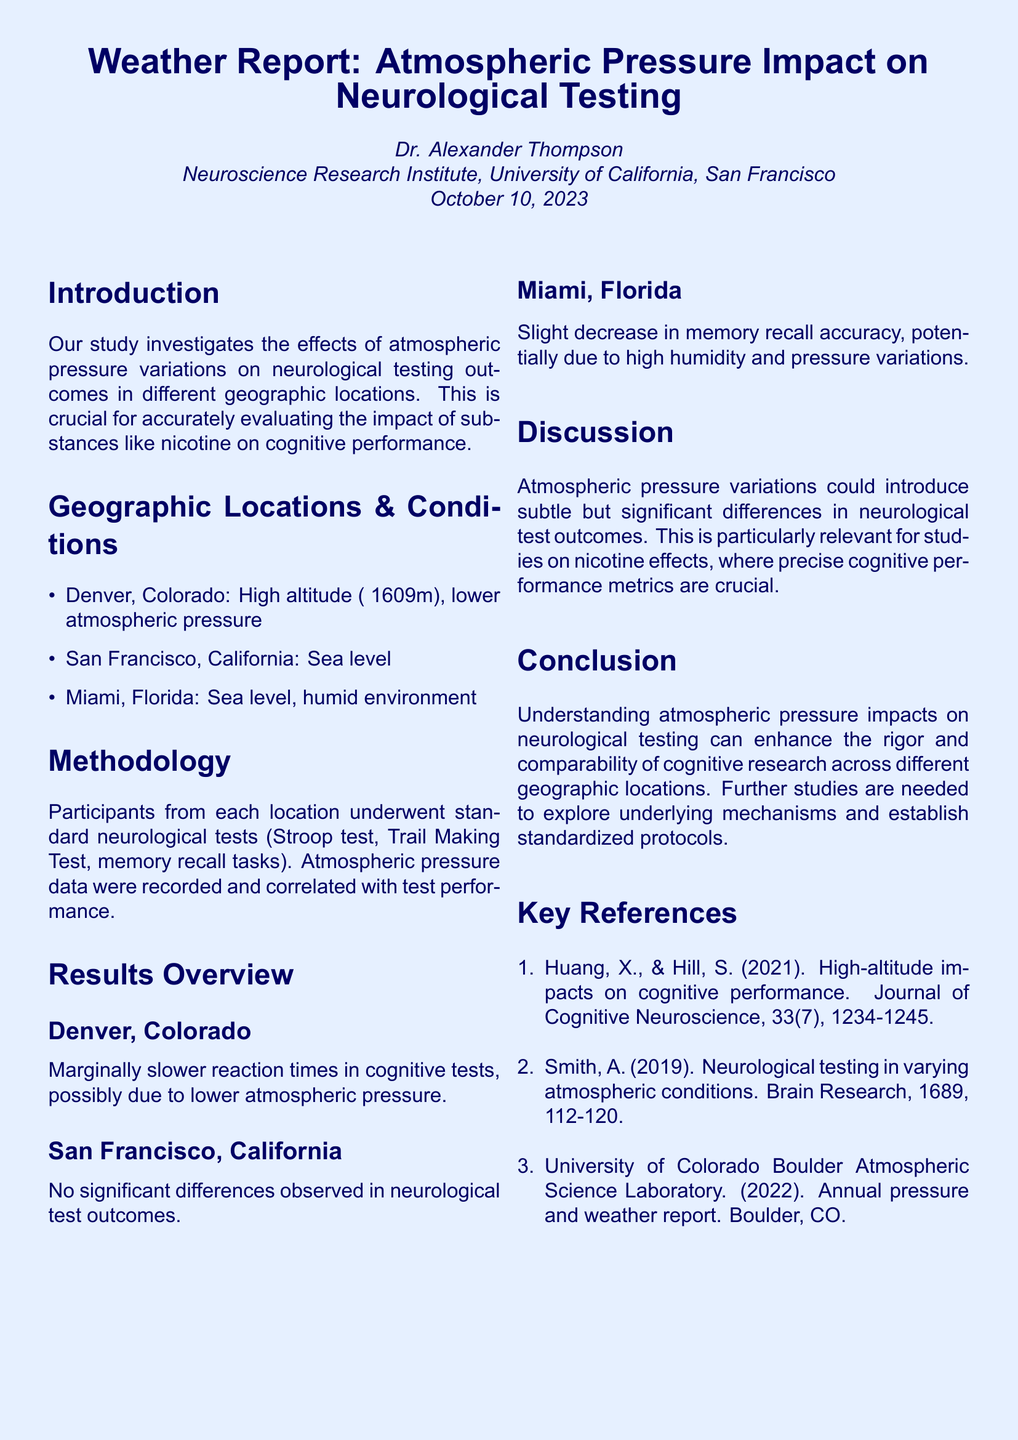what is the title of the report? The title can be found at the beginning of the document and is "Weather Report: Atmospheric Pressure Impact on Neurological Testing."
Answer: Weather Report: Atmospheric Pressure Impact on Neurological Testing who is the author of the report? The author is mentioned in the introductory section of the document.
Answer: Dr. Alexander Thompson what date was the report published? The date is specified in the introductory section.
Answer: October 10, 2023 what geographic location has the highest altitude? The geographic locations and their conditions are listed in the document.
Answer: Denver, Colorado what neurological test had marginally slower reaction times in Denver? The tests performed are listed in the methodology section, and the result relates specifically to reaction times.
Answer: cognitive tests which location showed no significant differences in neurological test outcomes? The results overview section provides insights into the performance outcomes for each location.
Answer: San Francisco, California which factor may have affected memory recall in Miami, Florida? The document discusses environmental conditions impacting performance outcomes.
Answer: high humidity and pressure variations what is one of the key references cited in the report? A list of key references is included at the end of the document.
Answer: Huang, X., & Hill, S. (2021). High-altitude impacts on cognitive performance 